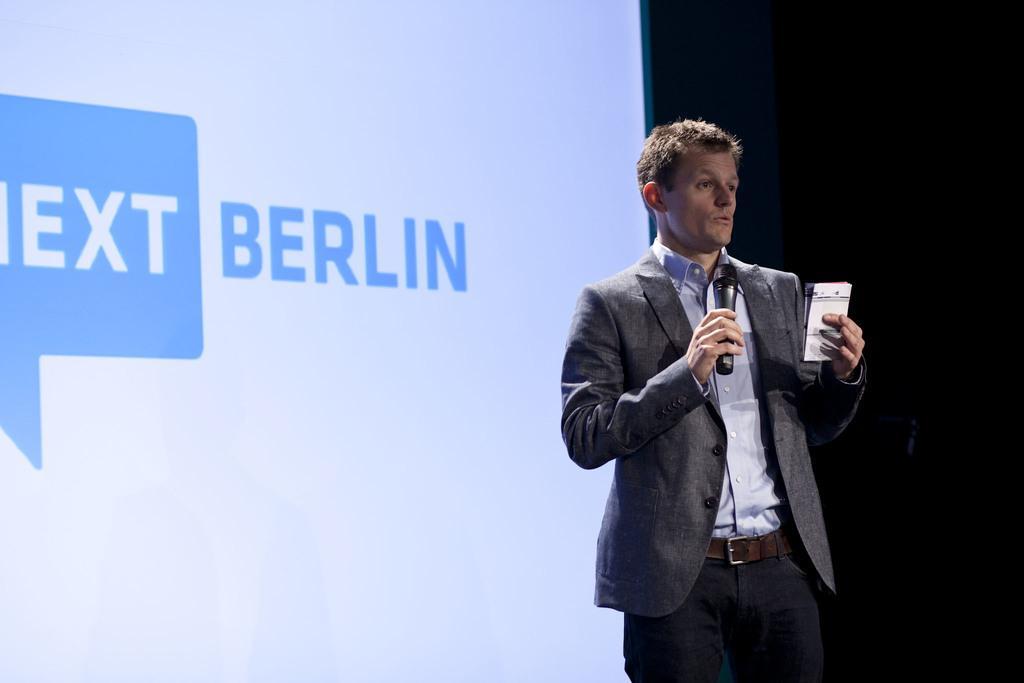How would you summarize this image in a sentence or two? At the background we can see a screen. Here we can see a man standing , holding a mike in his hand and talking. 